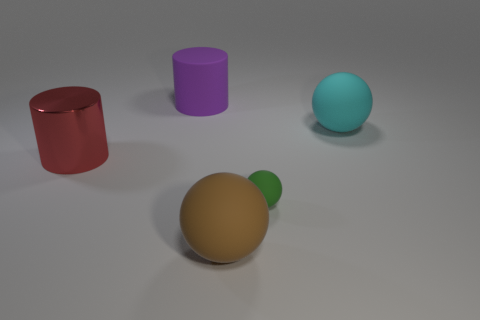Is there any other thing that has the same size as the green matte sphere?
Make the answer very short. No. Is there anything else that has the same material as the red object?
Provide a succinct answer. No. What number of large matte things are left of the brown thing?
Provide a succinct answer. 1. How big is the rubber object that is behind the green rubber thing and to the left of the cyan thing?
Ensure brevity in your answer.  Large. Are there any tiny gray balls?
Give a very brief answer. No. How many other objects are the same size as the green sphere?
Your response must be concise. 0. What is the size of the metal thing that is the same shape as the purple matte object?
Keep it short and to the point. Large. Is the large sphere that is behind the large red object made of the same material as the sphere to the left of the tiny ball?
Offer a terse response. Yes. What number of rubber things are small things or purple cylinders?
Offer a very short reply. 2. The large sphere that is right of the large matte object that is in front of the large cylinder on the left side of the large purple cylinder is made of what material?
Ensure brevity in your answer.  Rubber. 